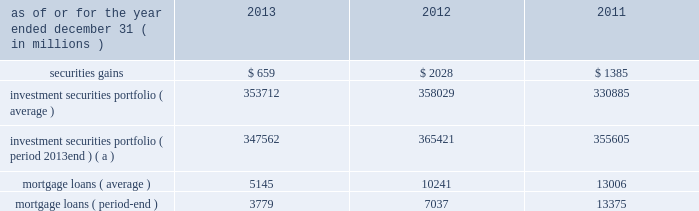Management 2019s discussion and analysis 110 jpmorgan chase & co./2013 annual report 2012 compared with 2011 net loss was $ 2.0 billion , compared with a net income of $ 919 million in the prior year .
Private equity reported net income of $ 292 million , compared with net income of $ 391 million in the prior year .
Net revenue was $ 601 million , compared with $ 836 million in the prior year , due to lower unrealized and realized gains on private investments , partially offset by higher unrealized gains on public securities .
Noninterest expense was $ 145 million , down from $ 238 million in the prior year .
Treasury and cio reported a net loss of $ 2.1 billion , compared with net income of $ 1.3 billion in the prior year .
Net revenue was a loss of $ 3.1 billion , compared with net revenue of $ 3.2 billion in the prior year .
The current year loss reflected $ 5.8 billion of losses incurred by cio from the synthetic credit portfolio for the six months ended june 30 , 2012 , and $ 449 million of losses from the retained index credit derivative positions for the three months ended september 30 , 2012 .
These losses were partially offset by securities gains of $ 2.0 billion .
The current year revenue reflected $ 888 million of extinguishment gains related to the redemption of trust preferred securities , which are included in all other income in the above table .
The extinguishment gains were related to adjustments applied to the cost basis of the trust preferred securities during the period they were in a qualified hedge accounting relationship .
Net interest income was negative $ 683 million , compared with $ 1.4 billion in the prior year , primarily reflecting the impact of lower portfolio yields and higher deposit balances across the firm .
Other corporate reported a net loss of $ 221 million , compared with a net loss of $ 821 million in the prior year .
Noninterest revenue of $ 1.8 billion was driven by a $ 1.1 billion benefit for the washington mutual bankruptcy settlement , which is included in all other income in the above table , and a $ 665 million gain from the recovery on a bear stearns-related subordinated loan .
Noninterest expense of $ 3.8 billion was up $ 1.0 billion compared with the prior year .
The current year included expense of $ 3.7 billion for additional litigation reserves , largely for mortgage-related matters .
The prior year included expense of $ 3.2 billion for additional litigation reserves .
Treasury and cio overview treasury and cio are predominantly responsible for measuring , monitoring , reporting and managing the firm 2019s liquidity , funding and structural interest rate and foreign exchange risks , as well as executing the firm 2019s capital plan .
The risks managed by treasury and cio arise from the activities undertaken by the firm 2019s four major reportable business segments to serve their respective client bases , which generate both on- and off-balance sheet assets and liabilities .
Cio achieves the firm 2019s asset-liability management objectives generally by investing in high-quality securities that are managed for the longer-term as part of the firm 2019s afs and htm investment securities portfolios ( the 201cinvestment securities portfolio 201d ) .
Cio also uses derivatives , as well as securities that are not classified as afs or htm , to meet the firm 2019s asset-liability management objectives .
For further information on derivatives , see note 6 on pages 220 2013233 of this annual report .
For further information about securities not classified within the afs or htm portfolio , see note 3 on pages 195 2013215 of this annual report .
The treasury and cio investment securities portfolio primarily consists of u.s .
And non-u.s .
Government securities , agency and non-agency mortgage-backed securities , other asset-backed securities , corporate debt securities and obligations of u.s .
States and municipalities .
At december 31 , 2013 , the total treasury and cio investment securities portfolio was $ 347.6 billion ; the average credit rating of the securities comprising the treasury and cio investment securities portfolio was aa+ ( based upon external ratings where available and where not available , based primarily upon internal ratings that correspond to ratings as defined by s&p and moody 2019s ) .
See note 12 on pages 249 2013254 of this annual report for further information on the details of the firm 2019s investment securities portfolio .
For further information on liquidity and funding risk , see liquidity risk management on pages 168 2013173 of this annual report .
For information on interest rate , foreign exchange and other risks , treasury and cio value-at-risk ( 201cvar 201d ) and the firm 2019s structural interest rate-sensitive revenue at risk , see market risk management on pages 142 2013148 of this annual report .
Selected income statement and balance sheet data as of or for the year ended december 31 , ( in millions ) 2013 2012 2011 .
( a ) period-end investment securities included held-to-maturity balance of $ 24.0 billion at december 31 , 2013 .
Held-to-maturity balances for the other periods were not material. .
In 2013 , what was the balance in the investment securities portfolio without htm securities , in us$ b? 
Computations: ((347562 / 1000) - 24.0)
Answer: 323.562. 